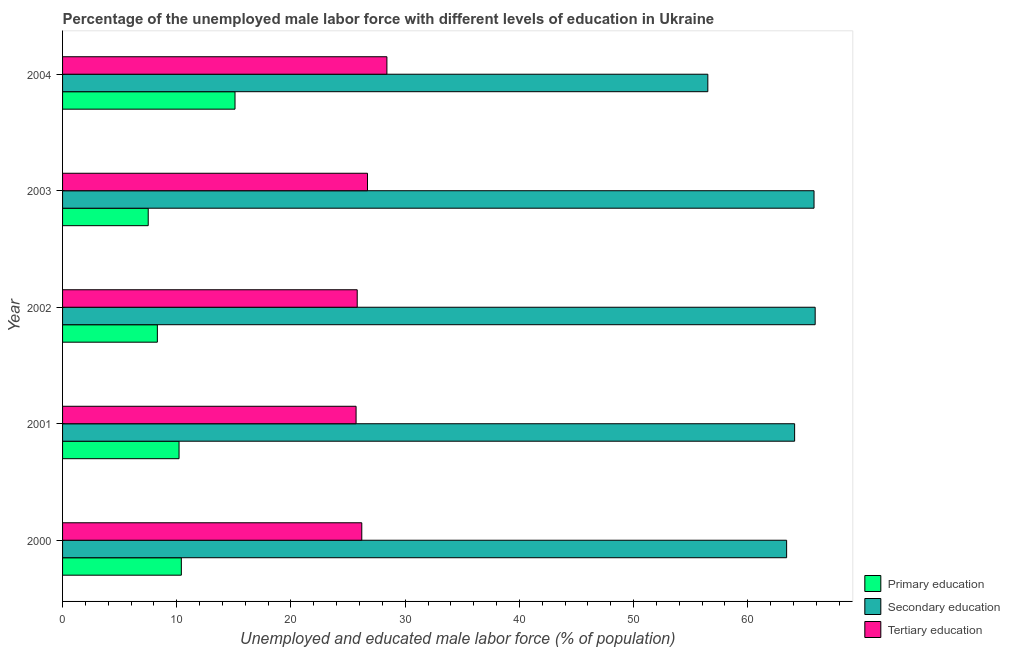How many different coloured bars are there?
Give a very brief answer. 3. Are the number of bars on each tick of the Y-axis equal?
Offer a terse response. Yes. How many bars are there on the 5th tick from the top?
Make the answer very short. 3. How many bars are there on the 4th tick from the bottom?
Ensure brevity in your answer.  3. What is the label of the 5th group of bars from the top?
Provide a short and direct response. 2000. What is the percentage of male labor force who received tertiary education in 2003?
Give a very brief answer. 26.7. Across all years, what is the maximum percentage of male labor force who received primary education?
Your answer should be compact. 15.1. Across all years, what is the minimum percentage of male labor force who received primary education?
Make the answer very short. 7.5. In which year was the percentage of male labor force who received tertiary education maximum?
Offer a very short reply. 2004. What is the total percentage of male labor force who received tertiary education in the graph?
Your response must be concise. 132.8. What is the difference between the percentage of male labor force who received primary education in 2001 and the percentage of male labor force who received tertiary education in 2000?
Make the answer very short. -16. What is the average percentage of male labor force who received secondary education per year?
Your answer should be compact. 63.14. In the year 2003, what is the difference between the percentage of male labor force who received primary education and percentage of male labor force who received tertiary education?
Make the answer very short. -19.2. In how many years, is the percentage of male labor force who received secondary education greater than 8 %?
Your answer should be compact. 5. What is the ratio of the percentage of male labor force who received primary education in 2000 to that in 2001?
Offer a terse response. 1.02. Is the percentage of male labor force who received tertiary education in 2001 less than that in 2002?
Your answer should be very brief. Yes. Is the difference between the percentage of male labor force who received secondary education in 2002 and 2004 greater than the difference between the percentage of male labor force who received tertiary education in 2002 and 2004?
Provide a short and direct response. Yes. What is the difference between the highest and the second highest percentage of male labor force who received secondary education?
Make the answer very short. 0.1. What does the 2nd bar from the top in 2001 represents?
Provide a succinct answer. Secondary education. Is it the case that in every year, the sum of the percentage of male labor force who received primary education and percentage of male labor force who received secondary education is greater than the percentage of male labor force who received tertiary education?
Your answer should be compact. Yes. How many bars are there?
Make the answer very short. 15. How many years are there in the graph?
Your response must be concise. 5. What is the difference between two consecutive major ticks on the X-axis?
Offer a very short reply. 10. Where does the legend appear in the graph?
Your answer should be very brief. Bottom right. What is the title of the graph?
Your answer should be very brief. Percentage of the unemployed male labor force with different levels of education in Ukraine. What is the label or title of the X-axis?
Provide a short and direct response. Unemployed and educated male labor force (% of population). What is the label or title of the Y-axis?
Your response must be concise. Year. What is the Unemployed and educated male labor force (% of population) of Primary education in 2000?
Make the answer very short. 10.4. What is the Unemployed and educated male labor force (% of population) of Secondary education in 2000?
Your answer should be compact. 63.4. What is the Unemployed and educated male labor force (% of population) in Tertiary education in 2000?
Make the answer very short. 26.2. What is the Unemployed and educated male labor force (% of population) in Primary education in 2001?
Your answer should be compact. 10.2. What is the Unemployed and educated male labor force (% of population) of Secondary education in 2001?
Provide a succinct answer. 64.1. What is the Unemployed and educated male labor force (% of population) in Tertiary education in 2001?
Provide a succinct answer. 25.7. What is the Unemployed and educated male labor force (% of population) in Primary education in 2002?
Ensure brevity in your answer.  8.3. What is the Unemployed and educated male labor force (% of population) in Secondary education in 2002?
Give a very brief answer. 65.9. What is the Unemployed and educated male labor force (% of population) in Tertiary education in 2002?
Your response must be concise. 25.8. What is the Unemployed and educated male labor force (% of population) of Primary education in 2003?
Ensure brevity in your answer.  7.5. What is the Unemployed and educated male labor force (% of population) of Secondary education in 2003?
Offer a very short reply. 65.8. What is the Unemployed and educated male labor force (% of population) in Tertiary education in 2003?
Give a very brief answer. 26.7. What is the Unemployed and educated male labor force (% of population) in Primary education in 2004?
Offer a terse response. 15.1. What is the Unemployed and educated male labor force (% of population) of Secondary education in 2004?
Keep it short and to the point. 56.5. What is the Unemployed and educated male labor force (% of population) of Tertiary education in 2004?
Your answer should be compact. 28.4. Across all years, what is the maximum Unemployed and educated male labor force (% of population) of Primary education?
Keep it short and to the point. 15.1. Across all years, what is the maximum Unemployed and educated male labor force (% of population) in Secondary education?
Keep it short and to the point. 65.9. Across all years, what is the maximum Unemployed and educated male labor force (% of population) of Tertiary education?
Offer a terse response. 28.4. Across all years, what is the minimum Unemployed and educated male labor force (% of population) of Secondary education?
Provide a succinct answer. 56.5. Across all years, what is the minimum Unemployed and educated male labor force (% of population) of Tertiary education?
Provide a short and direct response. 25.7. What is the total Unemployed and educated male labor force (% of population) in Primary education in the graph?
Offer a terse response. 51.5. What is the total Unemployed and educated male labor force (% of population) of Secondary education in the graph?
Provide a short and direct response. 315.7. What is the total Unemployed and educated male labor force (% of population) of Tertiary education in the graph?
Make the answer very short. 132.8. What is the difference between the Unemployed and educated male labor force (% of population) in Primary education in 2000 and that in 2001?
Give a very brief answer. 0.2. What is the difference between the Unemployed and educated male labor force (% of population) in Primary education in 2000 and that in 2002?
Provide a succinct answer. 2.1. What is the difference between the Unemployed and educated male labor force (% of population) in Tertiary education in 2000 and that in 2002?
Give a very brief answer. 0.4. What is the difference between the Unemployed and educated male labor force (% of population) in Tertiary education in 2000 and that in 2003?
Offer a very short reply. -0.5. What is the difference between the Unemployed and educated male labor force (% of population) of Primary education in 2000 and that in 2004?
Keep it short and to the point. -4.7. What is the difference between the Unemployed and educated male labor force (% of population) in Secondary education in 2000 and that in 2004?
Ensure brevity in your answer.  6.9. What is the difference between the Unemployed and educated male labor force (% of population) of Primary education in 2001 and that in 2002?
Offer a terse response. 1.9. What is the difference between the Unemployed and educated male labor force (% of population) of Primary education in 2001 and that in 2003?
Provide a short and direct response. 2.7. What is the difference between the Unemployed and educated male labor force (% of population) of Secondary education in 2001 and that in 2003?
Keep it short and to the point. -1.7. What is the difference between the Unemployed and educated male labor force (% of population) of Tertiary education in 2001 and that in 2003?
Your response must be concise. -1. What is the difference between the Unemployed and educated male labor force (% of population) of Tertiary education in 2001 and that in 2004?
Offer a terse response. -2.7. What is the difference between the Unemployed and educated male labor force (% of population) of Primary education in 2002 and that in 2003?
Your answer should be very brief. 0.8. What is the difference between the Unemployed and educated male labor force (% of population) of Tertiary education in 2003 and that in 2004?
Provide a short and direct response. -1.7. What is the difference between the Unemployed and educated male labor force (% of population) of Primary education in 2000 and the Unemployed and educated male labor force (% of population) of Secondary education in 2001?
Give a very brief answer. -53.7. What is the difference between the Unemployed and educated male labor force (% of population) of Primary education in 2000 and the Unemployed and educated male labor force (% of population) of Tertiary education in 2001?
Your response must be concise. -15.3. What is the difference between the Unemployed and educated male labor force (% of population) of Secondary education in 2000 and the Unemployed and educated male labor force (% of population) of Tertiary education in 2001?
Ensure brevity in your answer.  37.7. What is the difference between the Unemployed and educated male labor force (% of population) of Primary education in 2000 and the Unemployed and educated male labor force (% of population) of Secondary education in 2002?
Give a very brief answer. -55.5. What is the difference between the Unemployed and educated male labor force (% of population) of Primary education in 2000 and the Unemployed and educated male labor force (% of population) of Tertiary education in 2002?
Offer a very short reply. -15.4. What is the difference between the Unemployed and educated male labor force (% of population) in Secondary education in 2000 and the Unemployed and educated male labor force (% of population) in Tertiary education in 2002?
Ensure brevity in your answer.  37.6. What is the difference between the Unemployed and educated male labor force (% of population) in Primary education in 2000 and the Unemployed and educated male labor force (% of population) in Secondary education in 2003?
Your answer should be very brief. -55.4. What is the difference between the Unemployed and educated male labor force (% of population) in Primary education in 2000 and the Unemployed and educated male labor force (% of population) in Tertiary education in 2003?
Your response must be concise. -16.3. What is the difference between the Unemployed and educated male labor force (% of population) of Secondary education in 2000 and the Unemployed and educated male labor force (% of population) of Tertiary education in 2003?
Keep it short and to the point. 36.7. What is the difference between the Unemployed and educated male labor force (% of population) of Primary education in 2000 and the Unemployed and educated male labor force (% of population) of Secondary education in 2004?
Your answer should be very brief. -46.1. What is the difference between the Unemployed and educated male labor force (% of population) of Primary education in 2000 and the Unemployed and educated male labor force (% of population) of Tertiary education in 2004?
Your answer should be compact. -18. What is the difference between the Unemployed and educated male labor force (% of population) in Primary education in 2001 and the Unemployed and educated male labor force (% of population) in Secondary education in 2002?
Your answer should be compact. -55.7. What is the difference between the Unemployed and educated male labor force (% of population) of Primary education in 2001 and the Unemployed and educated male labor force (% of population) of Tertiary education in 2002?
Your response must be concise. -15.6. What is the difference between the Unemployed and educated male labor force (% of population) in Secondary education in 2001 and the Unemployed and educated male labor force (% of population) in Tertiary education in 2002?
Ensure brevity in your answer.  38.3. What is the difference between the Unemployed and educated male labor force (% of population) of Primary education in 2001 and the Unemployed and educated male labor force (% of population) of Secondary education in 2003?
Keep it short and to the point. -55.6. What is the difference between the Unemployed and educated male labor force (% of population) of Primary education in 2001 and the Unemployed and educated male labor force (% of population) of Tertiary education in 2003?
Offer a terse response. -16.5. What is the difference between the Unemployed and educated male labor force (% of population) of Secondary education in 2001 and the Unemployed and educated male labor force (% of population) of Tertiary education in 2003?
Make the answer very short. 37.4. What is the difference between the Unemployed and educated male labor force (% of population) of Primary education in 2001 and the Unemployed and educated male labor force (% of population) of Secondary education in 2004?
Ensure brevity in your answer.  -46.3. What is the difference between the Unemployed and educated male labor force (% of population) of Primary education in 2001 and the Unemployed and educated male labor force (% of population) of Tertiary education in 2004?
Your answer should be very brief. -18.2. What is the difference between the Unemployed and educated male labor force (% of population) in Secondary education in 2001 and the Unemployed and educated male labor force (% of population) in Tertiary education in 2004?
Ensure brevity in your answer.  35.7. What is the difference between the Unemployed and educated male labor force (% of population) in Primary education in 2002 and the Unemployed and educated male labor force (% of population) in Secondary education in 2003?
Provide a succinct answer. -57.5. What is the difference between the Unemployed and educated male labor force (% of population) of Primary education in 2002 and the Unemployed and educated male labor force (% of population) of Tertiary education in 2003?
Offer a terse response. -18.4. What is the difference between the Unemployed and educated male labor force (% of population) in Secondary education in 2002 and the Unemployed and educated male labor force (% of population) in Tertiary education in 2003?
Provide a succinct answer. 39.2. What is the difference between the Unemployed and educated male labor force (% of population) in Primary education in 2002 and the Unemployed and educated male labor force (% of population) in Secondary education in 2004?
Provide a short and direct response. -48.2. What is the difference between the Unemployed and educated male labor force (% of population) of Primary education in 2002 and the Unemployed and educated male labor force (% of population) of Tertiary education in 2004?
Keep it short and to the point. -20.1. What is the difference between the Unemployed and educated male labor force (% of population) of Secondary education in 2002 and the Unemployed and educated male labor force (% of population) of Tertiary education in 2004?
Give a very brief answer. 37.5. What is the difference between the Unemployed and educated male labor force (% of population) of Primary education in 2003 and the Unemployed and educated male labor force (% of population) of Secondary education in 2004?
Your answer should be very brief. -49. What is the difference between the Unemployed and educated male labor force (% of population) in Primary education in 2003 and the Unemployed and educated male labor force (% of population) in Tertiary education in 2004?
Offer a terse response. -20.9. What is the difference between the Unemployed and educated male labor force (% of population) of Secondary education in 2003 and the Unemployed and educated male labor force (% of population) of Tertiary education in 2004?
Make the answer very short. 37.4. What is the average Unemployed and educated male labor force (% of population) in Secondary education per year?
Give a very brief answer. 63.14. What is the average Unemployed and educated male labor force (% of population) of Tertiary education per year?
Your answer should be compact. 26.56. In the year 2000, what is the difference between the Unemployed and educated male labor force (% of population) of Primary education and Unemployed and educated male labor force (% of population) of Secondary education?
Offer a very short reply. -53. In the year 2000, what is the difference between the Unemployed and educated male labor force (% of population) of Primary education and Unemployed and educated male labor force (% of population) of Tertiary education?
Make the answer very short. -15.8. In the year 2000, what is the difference between the Unemployed and educated male labor force (% of population) in Secondary education and Unemployed and educated male labor force (% of population) in Tertiary education?
Give a very brief answer. 37.2. In the year 2001, what is the difference between the Unemployed and educated male labor force (% of population) in Primary education and Unemployed and educated male labor force (% of population) in Secondary education?
Offer a terse response. -53.9. In the year 2001, what is the difference between the Unemployed and educated male labor force (% of population) of Primary education and Unemployed and educated male labor force (% of population) of Tertiary education?
Provide a short and direct response. -15.5. In the year 2001, what is the difference between the Unemployed and educated male labor force (% of population) of Secondary education and Unemployed and educated male labor force (% of population) of Tertiary education?
Make the answer very short. 38.4. In the year 2002, what is the difference between the Unemployed and educated male labor force (% of population) of Primary education and Unemployed and educated male labor force (% of population) of Secondary education?
Ensure brevity in your answer.  -57.6. In the year 2002, what is the difference between the Unemployed and educated male labor force (% of population) in Primary education and Unemployed and educated male labor force (% of population) in Tertiary education?
Offer a very short reply. -17.5. In the year 2002, what is the difference between the Unemployed and educated male labor force (% of population) in Secondary education and Unemployed and educated male labor force (% of population) in Tertiary education?
Ensure brevity in your answer.  40.1. In the year 2003, what is the difference between the Unemployed and educated male labor force (% of population) in Primary education and Unemployed and educated male labor force (% of population) in Secondary education?
Your answer should be very brief. -58.3. In the year 2003, what is the difference between the Unemployed and educated male labor force (% of population) of Primary education and Unemployed and educated male labor force (% of population) of Tertiary education?
Your answer should be very brief. -19.2. In the year 2003, what is the difference between the Unemployed and educated male labor force (% of population) of Secondary education and Unemployed and educated male labor force (% of population) of Tertiary education?
Keep it short and to the point. 39.1. In the year 2004, what is the difference between the Unemployed and educated male labor force (% of population) in Primary education and Unemployed and educated male labor force (% of population) in Secondary education?
Your answer should be compact. -41.4. In the year 2004, what is the difference between the Unemployed and educated male labor force (% of population) in Primary education and Unemployed and educated male labor force (% of population) in Tertiary education?
Make the answer very short. -13.3. In the year 2004, what is the difference between the Unemployed and educated male labor force (% of population) in Secondary education and Unemployed and educated male labor force (% of population) in Tertiary education?
Make the answer very short. 28.1. What is the ratio of the Unemployed and educated male labor force (% of population) in Primary education in 2000 to that in 2001?
Your response must be concise. 1.02. What is the ratio of the Unemployed and educated male labor force (% of population) of Secondary education in 2000 to that in 2001?
Your answer should be very brief. 0.99. What is the ratio of the Unemployed and educated male labor force (% of population) of Tertiary education in 2000 to that in 2001?
Keep it short and to the point. 1.02. What is the ratio of the Unemployed and educated male labor force (% of population) in Primary education in 2000 to that in 2002?
Make the answer very short. 1.25. What is the ratio of the Unemployed and educated male labor force (% of population) in Secondary education in 2000 to that in 2002?
Keep it short and to the point. 0.96. What is the ratio of the Unemployed and educated male labor force (% of population) of Tertiary education in 2000 to that in 2002?
Your response must be concise. 1.02. What is the ratio of the Unemployed and educated male labor force (% of population) in Primary education in 2000 to that in 2003?
Ensure brevity in your answer.  1.39. What is the ratio of the Unemployed and educated male labor force (% of population) of Secondary education in 2000 to that in 2003?
Provide a short and direct response. 0.96. What is the ratio of the Unemployed and educated male labor force (% of population) of Tertiary education in 2000 to that in 2003?
Provide a succinct answer. 0.98. What is the ratio of the Unemployed and educated male labor force (% of population) in Primary education in 2000 to that in 2004?
Provide a short and direct response. 0.69. What is the ratio of the Unemployed and educated male labor force (% of population) in Secondary education in 2000 to that in 2004?
Your response must be concise. 1.12. What is the ratio of the Unemployed and educated male labor force (% of population) of Tertiary education in 2000 to that in 2004?
Keep it short and to the point. 0.92. What is the ratio of the Unemployed and educated male labor force (% of population) of Primary education in 2001 to that in 2002?
Provide a succinct answer. 1.23. What is the ratio of the Unemployed and educated male labor force (% of population) in Secondary education in 2001 to that in 2002?
Your answer should be compact. 0.97. What is the ratio of the Unemployed and educated male labor force (% of population) in Tertiary education in 2001 to that in 2002?
Your answer should be compact. 1. What is the ratio of the Unemployed and educated male labor force (% of population) of Primary education in 2001 to that in 2003?
Provide a short and direct response. 1.36. What is the ratio of the Unemployed and educated male labor force (% of population) of Secondary education in 2001 to that in 2003?
Give a very brief answer. 0.97. What is the ratio of the Unemployed and educated male labor force (% of population) of Tertiary education in 2001 to that in 2003?
Give a very brief answer. 0.96. What is the ratio of the Unemployed and educated male labor force (% of population) of Primary education in 2001 to that in 2004?
Your answer should be very brief. 0.68. What is the ratio of the Unemployed and educated male labor force (% of population) in Secondary education in 2001 to that in 2004?
Your answer should be very brief. 1.13. What is the ratio of the Unemployed and educated male labor force (% of population) of Tertiary education in 2001 to that in 2004?
Your answer should be very brief. 0.9. What is the ratio of the Unemployed and educated male labor force (% of population) of Primary education in 2002 to that in 2003?
Offer a very short reply. 1.11. What is the ratio of the Unemployed and educated male labor force (% of population) of Secondary education in 2002 to that in 2003?
Make the answer very short. 1. What is the ratio of the Unemployed and educated male labor force (% of population) of Tertiary education in 2002 to that in 2003?
Your response must be concise. 0.97. What is the ratio of the Unemployed and educated male labor force (% of population) in Primary education in 2002 to that in 2004?
Provide a succinct answer. 0.55. What is the ratio of the Unemployed and educated male labor force (% of population) of Secondary education in 2002 to that in 2004?
Keep it short and to the point. 1.17. What is the ratio of the Unemployed and educated male labor force (% of population) in Tertiary education in 2002 to that in 2004?
Provide a succinct answer. 0.91. What is the ratio of the Unemployed and educated male labor force (% of population) in Primary education in 2003 to that in 2004?
Your response must be concise. 0.5. What is the ratio of the Unemployed and educated male labor force (% of population) in Secondary education in 2003 to that in 2004?
Offer a very short reply. 1.16. What is the ratio of the Unemployed and educated male labor force (% of population) of Tertiary education in 2003 to that in 2004?
Provide a short and direct response. 0.94. What is the difference between the highest and the second highest Unemployed and educated male labor force (% of population) in Primary education?
Provide a succinct answer. 4.7. What is the difference between the highest and the second highest Unemployed and educated male labor force (% of population) of Secondary education?
Your response must be concise. 0.1. What is the difference between the highest and the second highest Unemployed and educated male labor force (% of population) of Tertiary education?
Keep it short and to the point. 1.7. What is the difference between the highest and the lowest Unemployed and educated male labor force (% of population) of Secondary education?
Offer a very short reply. 9.4. What is the difference between the highest and the lowest Unemployed and educated male labor force (% of population) in Tertiary education?
Provide a succinct answer. 2.7. 